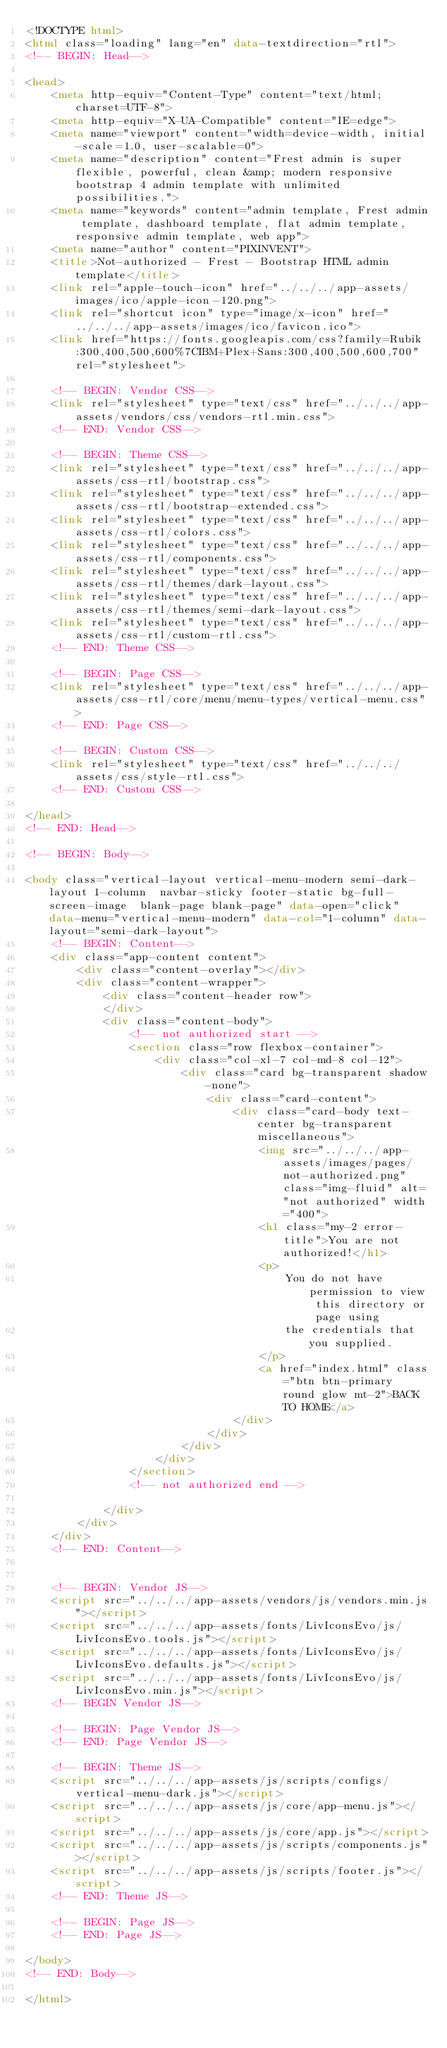<code> <loc_0><loc_0><loc_500><loc_500><_HTML_><!DOCTYPE html>
<html class="loading" lang="en" data-textdirection="rtl">
<!-- BEGIN: Head-->

<head>
    <meta http-equiv="Content-Type" content="text/html; charset=UTF-8">
    <meta http-equiv="X-UA-Compatible" content="IE=edge">
    <meta name="viewport" content="width=device-width, initial-scale=1.0, user-scalable=0">
    <meta name="description" content="Frest admin is super flexible, powerful, clean &amp; modern responsive bootstrap 4 admin template with unlimited possibilities.">
    <meta name="keywords" content="admin template, Frest admin template, dashboard template, flat admin template, responsive admin template, web app">
    <meta name="author" content="PIXINVENT">
    <title>Not-authorized - Frest - Bootstrap HTML admin template</title>
    <link rel="apple-touch-icon" href="../../../app-assets/images/ico/apple-icon-120.png">
    <link rel="shortcut icon" type="image/x-icon" href="../../../app-assets/images/ico/favicon.ico">
    <link href="https://fonts.googleapis.com/css?family=Rubik:300,400,500,600%7CIBM+Plex+Sans:300,400,500,600,700" rel="stylesheet">

    <!-- BEGIN: Vendor CSS-->
    <link rel="stylesheet" type="text/css" href="../../../app-assets/vendors/css/vendors-rtl.min.css">
    <!-- END: Vendor CSS-->

    <!-- BEGIN: Theme CSS-->
    <link rel="stylesheet" type="text/css" href="../../../app-assets/css-rtl/bootstrap.css">
    <link rel="stylesheet" type="text/css" href="../../../app-assets/css-rtl/bootstrap-extended.css">
    <link rel="stylesheet" type="text/css" href="../../../app-assets/css-rtl/colors.css">
    <link rel="stylesheet" type="text/css" href="../../../app-assets/css-rtl/components.css">
    <link rel="stylesheet" type="text/css" href="../../../app-assets/css-rtl/themes/dark-layout.css">
    <link rel="stylesheet" type="text/css" href="../../../app-assets/css-rtl/themes/semi-dark-layout.css">
    <link rel="stylesheet" type="text/css" href="../../../app-assets/css-rtl/custom-rtl.css">
    <!-- END: Theme CSS-->

    <!-- BEGIN: Page CSS-->
    <link rel="stylesheet" type="text/css" href="../../../app-assets/css-rtl/core/menu/menu-types/vertical-menu.css">
    <!-- END: Page CSS-->

    <!-- BEGIN: Custom CSS-->
    <link rel="stylesheet" type="text/css" href="../../../assets/css/style-rtl.css">
    <!-- END: Custom CSS-->

</head>
<!-- END: Head-->

<!-- BEGIN: Body-->

<body class="vertical-layout vertical-menu-modern semi-dark-layout 1-column  navbar-sticky footer-static bg-full-screen-image  blank-page blank-page" data-open="click" data-menu="vertical-menu-modern" data-col="1-column" data-layout="semi-dark-layout">
    <!-- BEGIN: Content-->
    <div class="app-content content">
        <div class="content-overlay"></div>
        <div class="content-wrapper">
            <div class="content-header row">
            </div>
            <div class="content-body">
                <!-- not authorized start -->
                <section class="row flexbox-container">
                    <div class="col-xl-7 col-md-8 col-12">
                        <div class="card bg-transparent shadow-none">
                            <div class="card-content">
                                <div class="card-body text-center bg-transparent miscellaneous">
                                    <img src="../../../app-assets/images/pages/not-authorized.png" class="img-fluid" alt="not authorized" width="400">
                                    <h1 class="my-2 error-title">You are not authorized!</h1>
                                    <p>
                                        You do not have permission to view this directory or page using
                                        the credentials that you supplied.
                                    </p>
                                    <a href="index.html" class="btn btn-primary round glow mt-2">BACK TO HOME</a>
                                </div>
                            </div>
                        </div>
                    </div>
                </section>
                <!-- not authorized end -->

            </div>
        </div>
    </div>
    <!-- END: Content-->


    <!-- BEGIN: Vendor JS-->
    <script src="../../../app-assets/vendors/js/vendors.min.js"></script>
    <script src="../../../app-assets/fonts/LivIconsEvo/js/LivIconsEvo.tools.js"></script>
    <script src="../../../app-assets/fonts/LivIconsEvo/js/LivIconsEvo.defaults.js"></script>
    <script src="../../../app-assets/fonts/LivIconsEvo/js/LivIconsEvo.min.js"></script>
    <!-- BEGIN Vendor JS-->

    <!-- BEGIN: Page Vendor JS-->
    <!-- END: Page Vendor JS-->

    <!-- BEGIN: Theme JS-->
    <script src="../../../app-assets/js/scripts/configs/vertical-menu-dark.js"></script>
    <script src="../../../app-assets/js/core/app-menu.js"></script>
    <script src="../../../app-assets/js/core/app.js"></script>
    <script src="../../../app-assets/js/scripts/components.js"></script>
    <script src="../../../app-assets/js/scripts/footer.js"></script>
    <!-- END: Theme JS-->

    <!-- BEGIN: Page JS-->
    <!-- END: Page JS-->

</body>
<!-- END: Body-->

</html></code> 